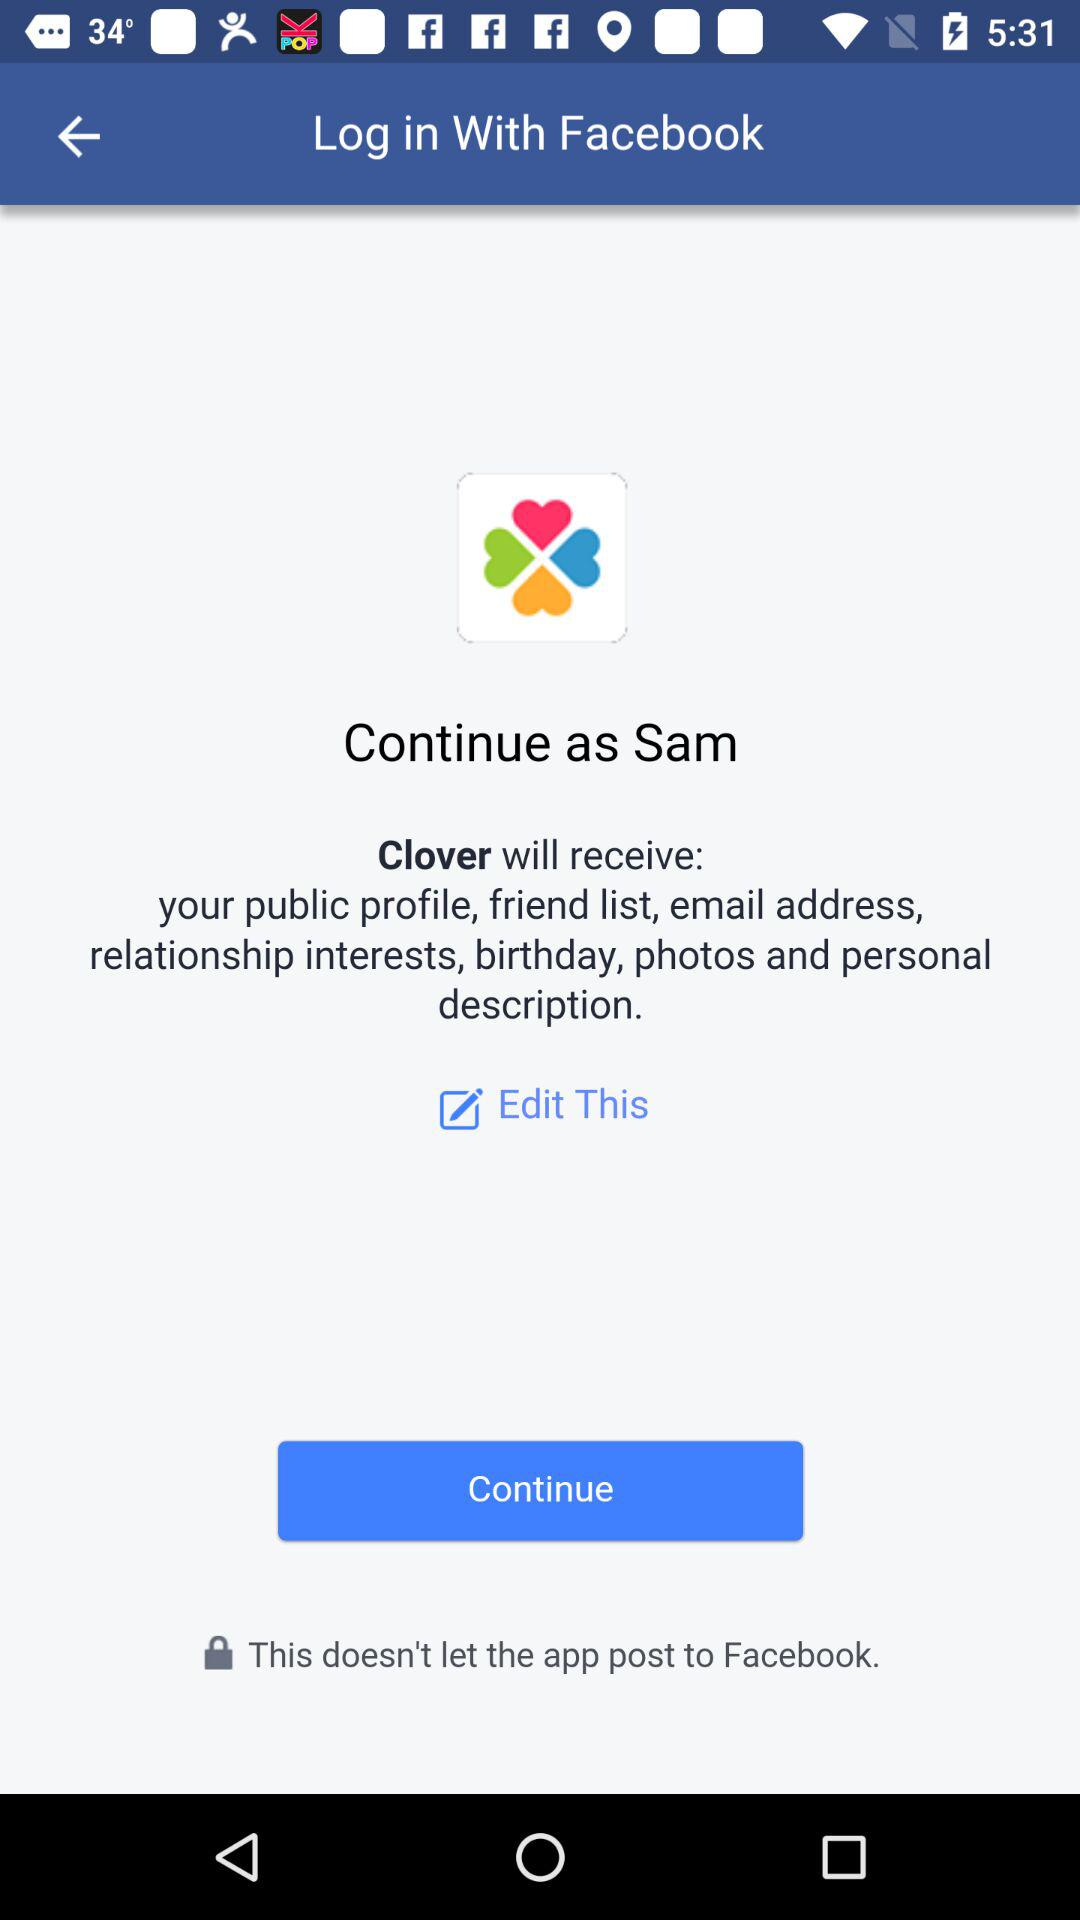What application will receive my public profile, friend list, email address, relationship interests, birthday, photos and personal description? The application is "Clover". 